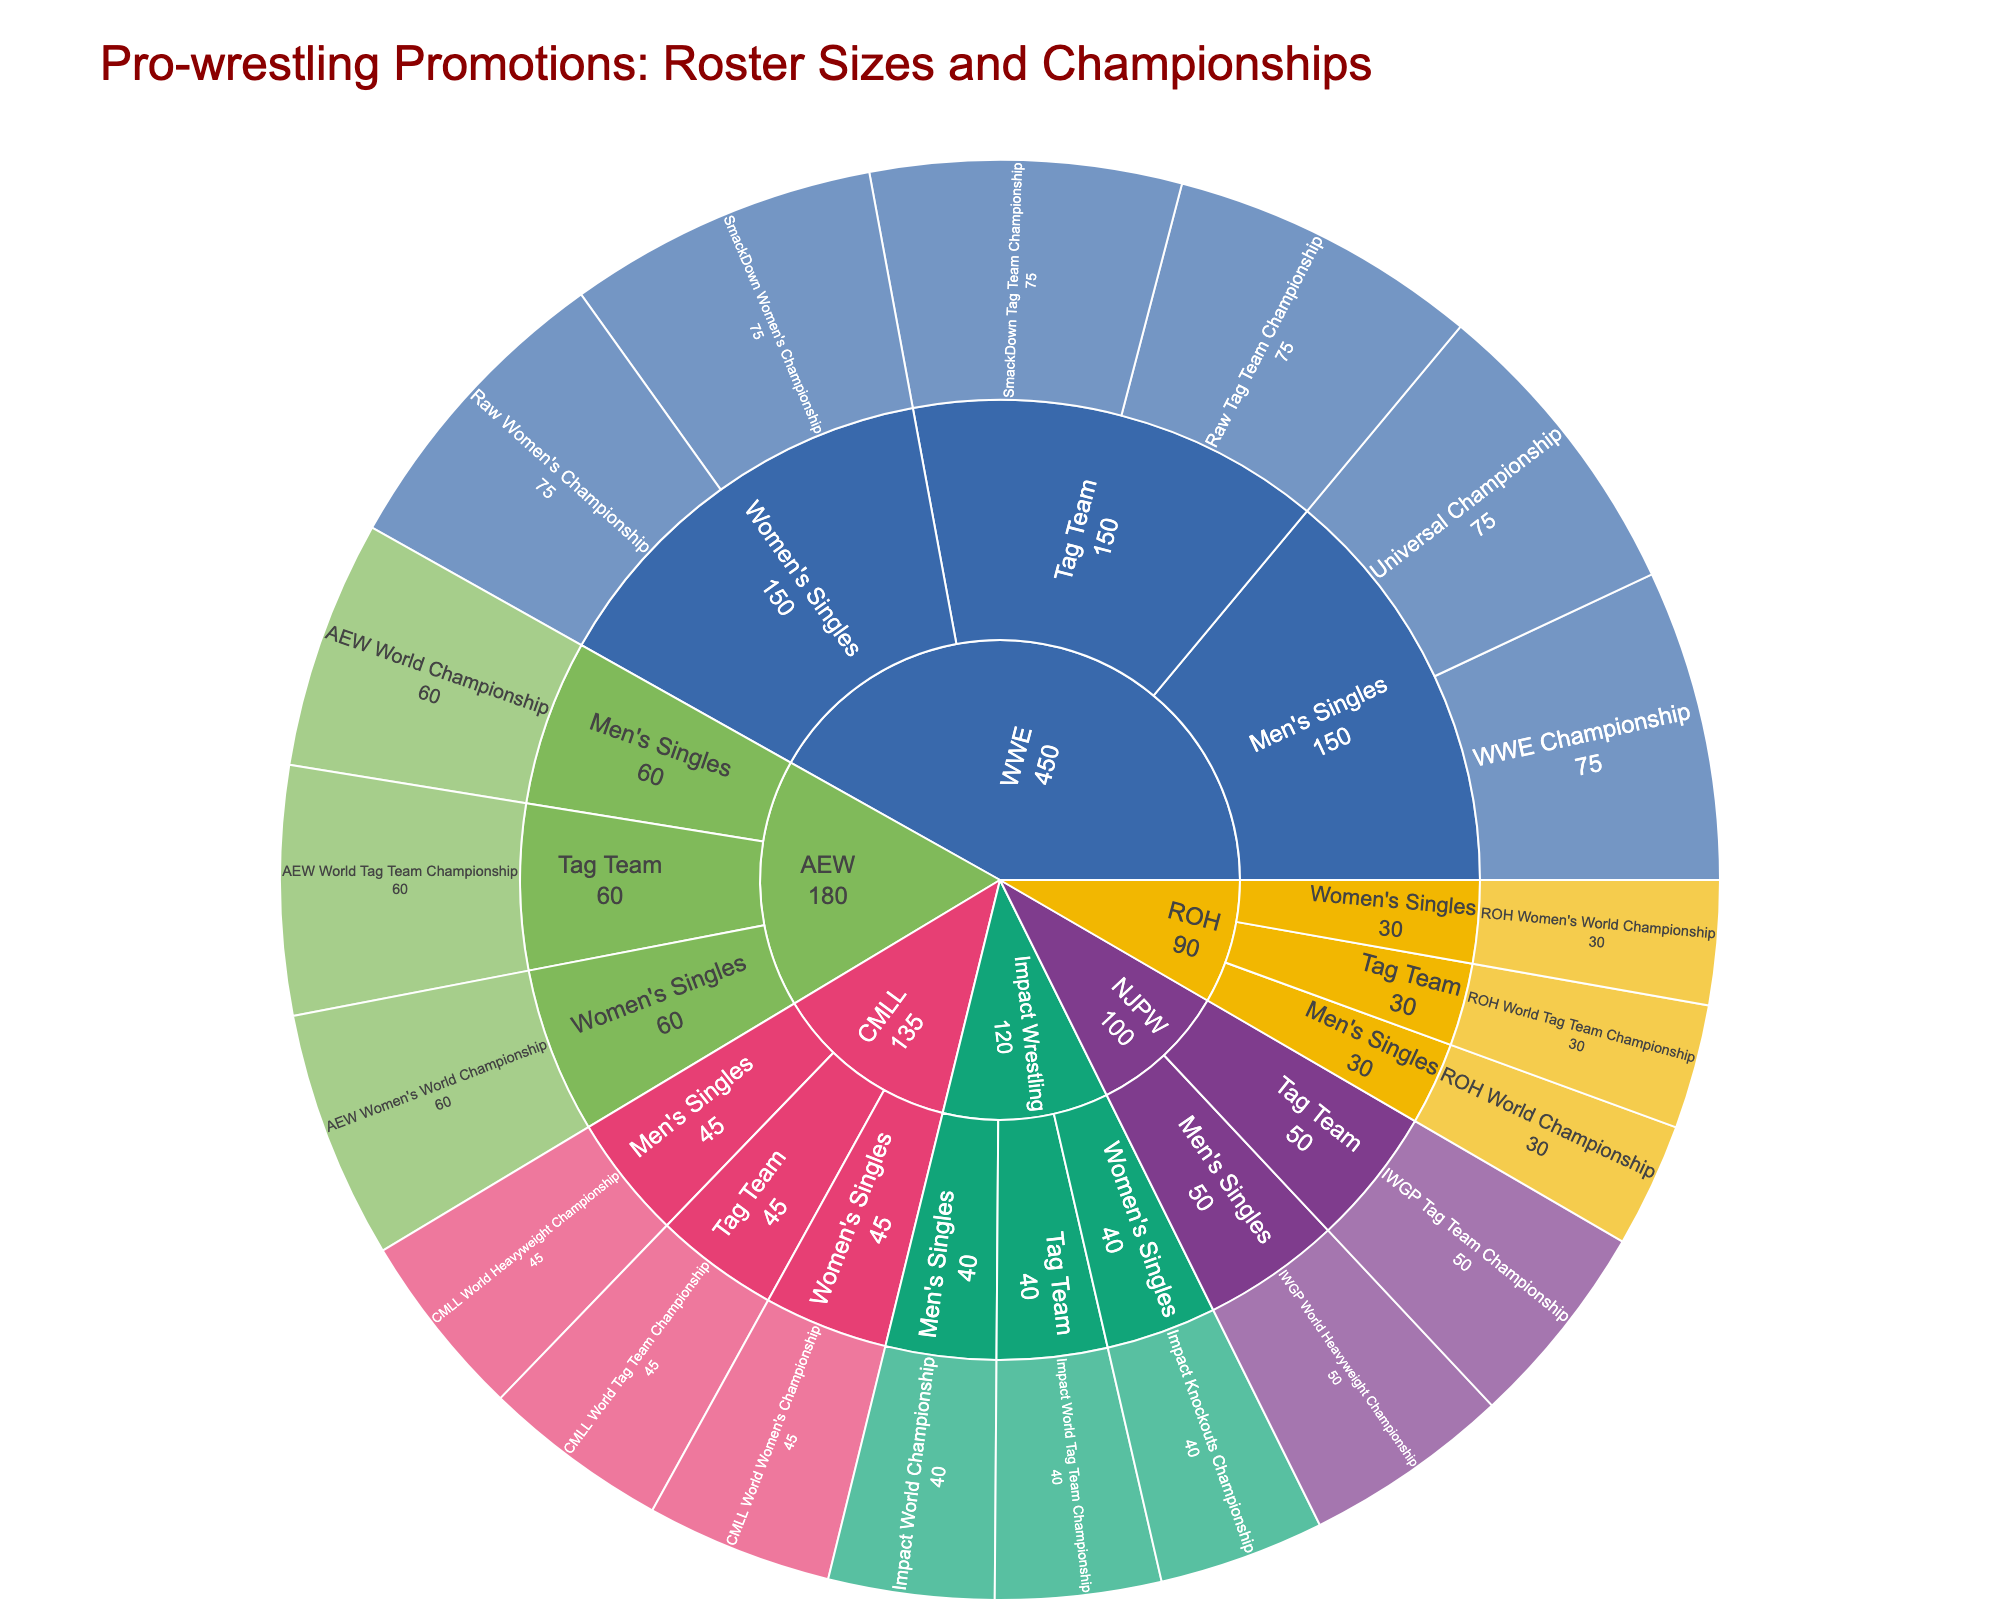what's the title of the figure? The title is typically located at the top of the figure and provides a brief description of what the visualization represents. The title here is "Pro-wrestling Promotions: Roster Sizes and Championships".
Answer: Pro-wrestling Promotions: Roster Sizes and Championships Which promotion has the largest roster size? Look at the outer ring of the sunburst plot, largest sectors represent bigger roster sizes. "WWE" with 75 members appears as the largest sector.
Answer: WWE Which championship divisions are included in the promotion "AEW"? Find and trace the "AEW" section in the plot to its sub-divisions. AEW has divisions "Men's Singles," "Women's Singles," and "Tag Team" with championships under each.
Answer: Men's Singles, Women's Singles, Tag Team How many championship divisions does "CMLL" have? Look for the section labeled "CMLL" and count its primary divisions. There are three: "Men's Singles," "Women's Singles," and "Tag Team".
Answer: 3 What's the combined roster size of "NJPW" and "Impact Wrestling"? Locate both "NJPW" and "Impact Wrestling" sections and add their roster sizes (50 + 40).
Answer: 90 Which promotion has more roster members, AEW or ROH? Compare the roster sizes of AEW and ROH, AEW has 60 members while ROH has 30. AEW has more.
Answer: AEW What is the unique feature of "ROH" compared to other promotions in terms of the number of roster members? Observe the number of members for each promotion, ROH has the smallest roster size with only 30 members.
Answer: Smallest roster size Which division in "WWE" handles the most championship categories? Look at the divisions under "WWE" and count the championship categories. "Men's Singles" and "Women's Singles" both have 2 championships, and "Tag Team" also has 2 championships. So, they are equal in number.
Answer: Men's Singles, Women's Singles, Tag Team (Equal) What's the roster size for promotions that have a Women's Singles division? Sum the roster sizes of all promotions that include a Women's Singles division: WWE (75), AEW (60), Impact Wrestling (40), ROH (30), and CMLL (45). The total is 75 + 60 + 40 + 30 + 45 = 250.
Answer: 250 Between "Impact Wrestling" and "CMLL," which promotion has more tag team divisions? Compare the "Tag Team" divisions of both, and both "Impact Wrestling" and "CMLL" have 1 tag team division each. Therefore, they are equal.
Answer: Equal 